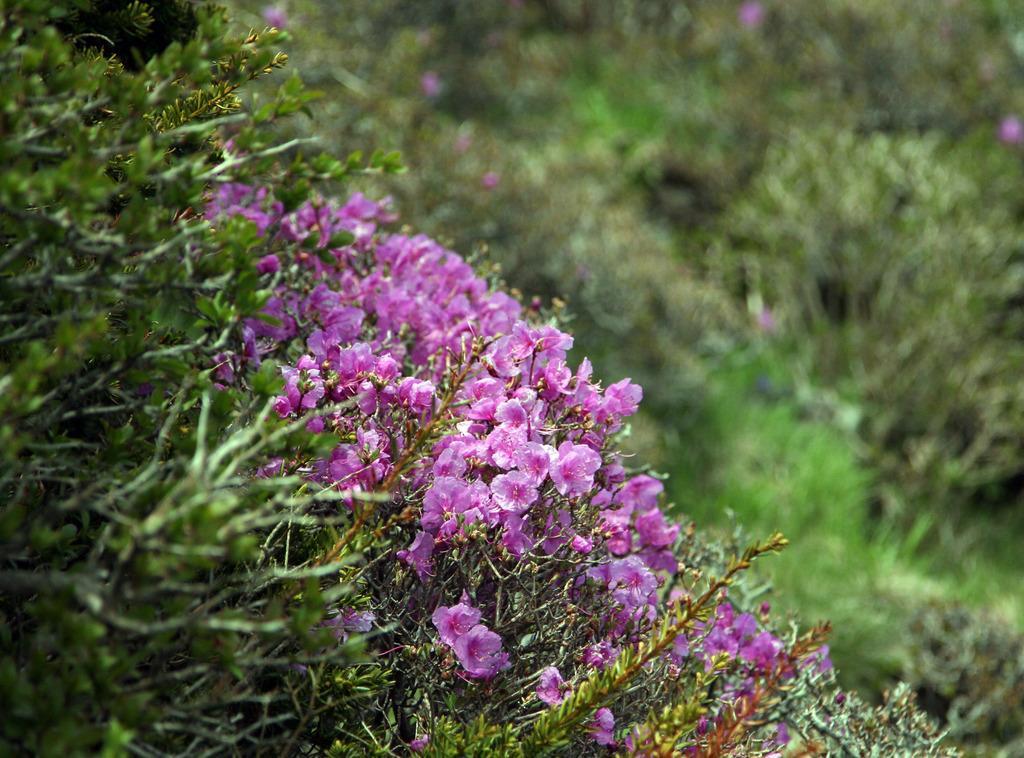In one or two sentences, can you explain what this image depicts? In this picture I can see plants with pink flowers, and there is blur background. 